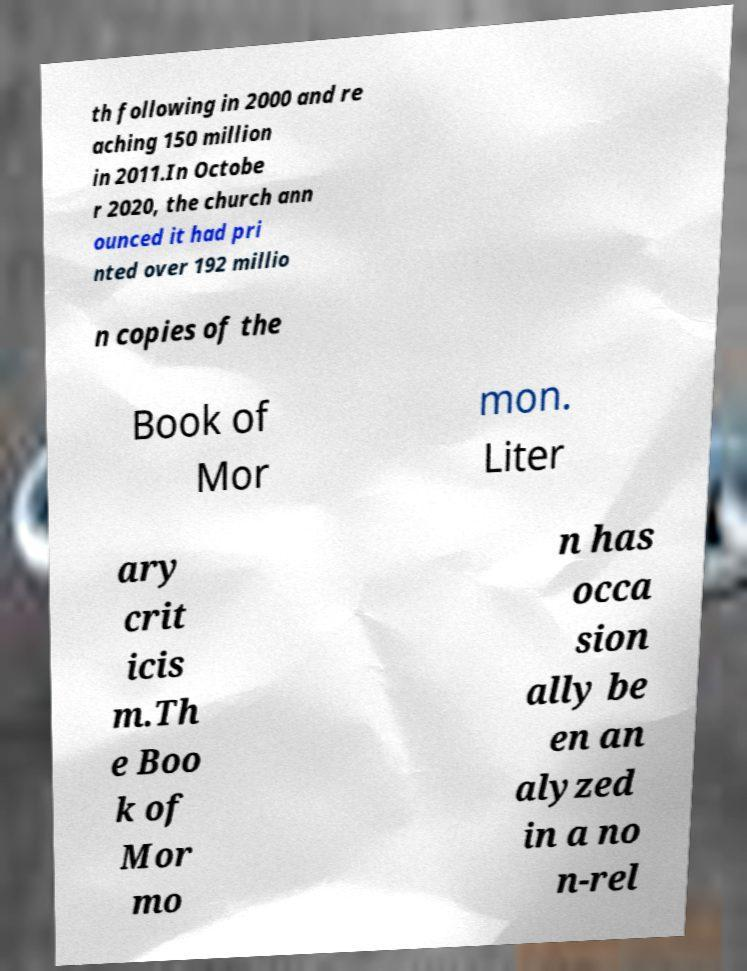There's text embedded in this image that I need extracted. Can you transcribe it verbatim? th following in 2000 and re aching 150 million in 2011.In Octobe r 2020, the church ann ounced it had pri nted over 192 millio n copies of the Book of Mor mon. Liter ary crit icis m.Th e Boo k of Mor mo n has occa sion ally be en an alyzed in a no n-rel 